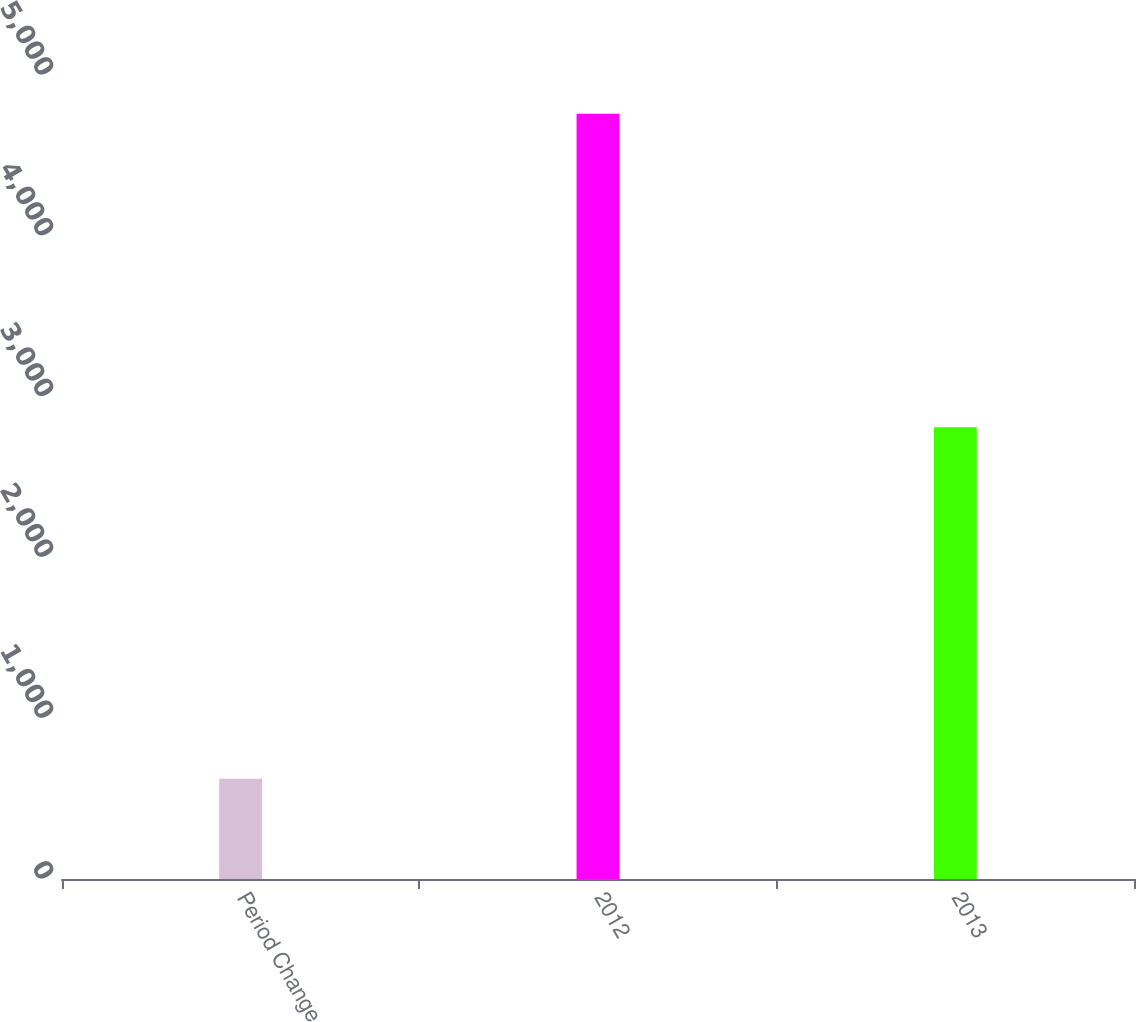<chart> <loc_0><loc_0><loc_500><loc_500><bar_chart><fcel>Period Change<fcel>2012<fcel>2013<nl><fcel>624<fcel>4759<fcel>2809<nl></chart> 